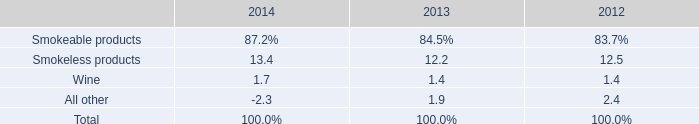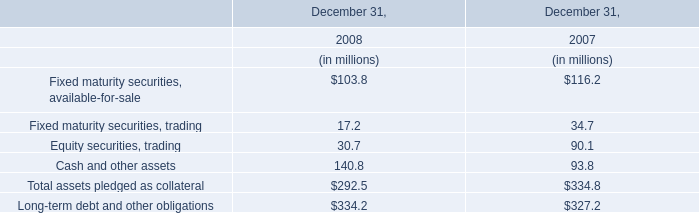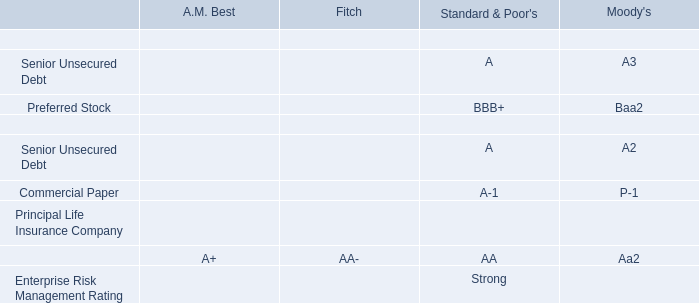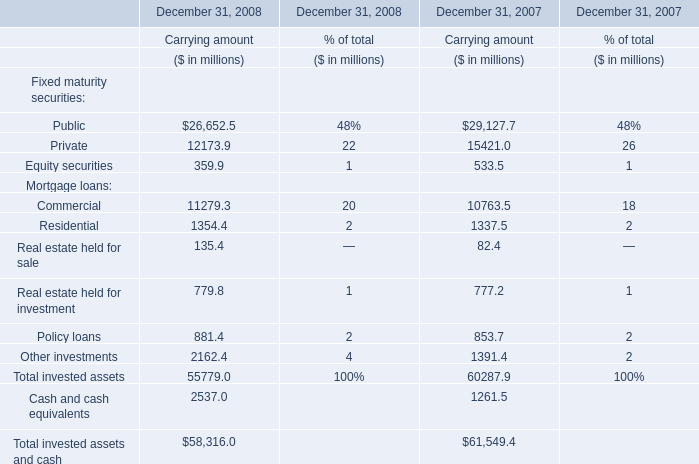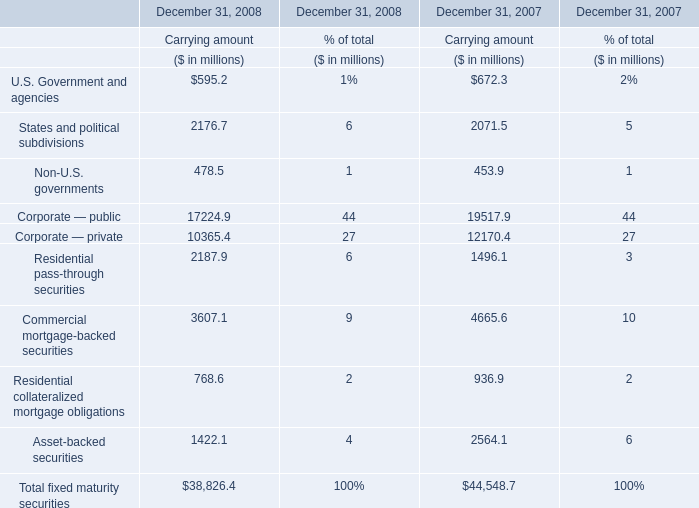how did the percentage of operating income related to smokeless product change from 2013 to 2014 relative the total operating income? 
Computations: ((13.4 - 12.2) / 12.2)
Answer: 0.09836. 